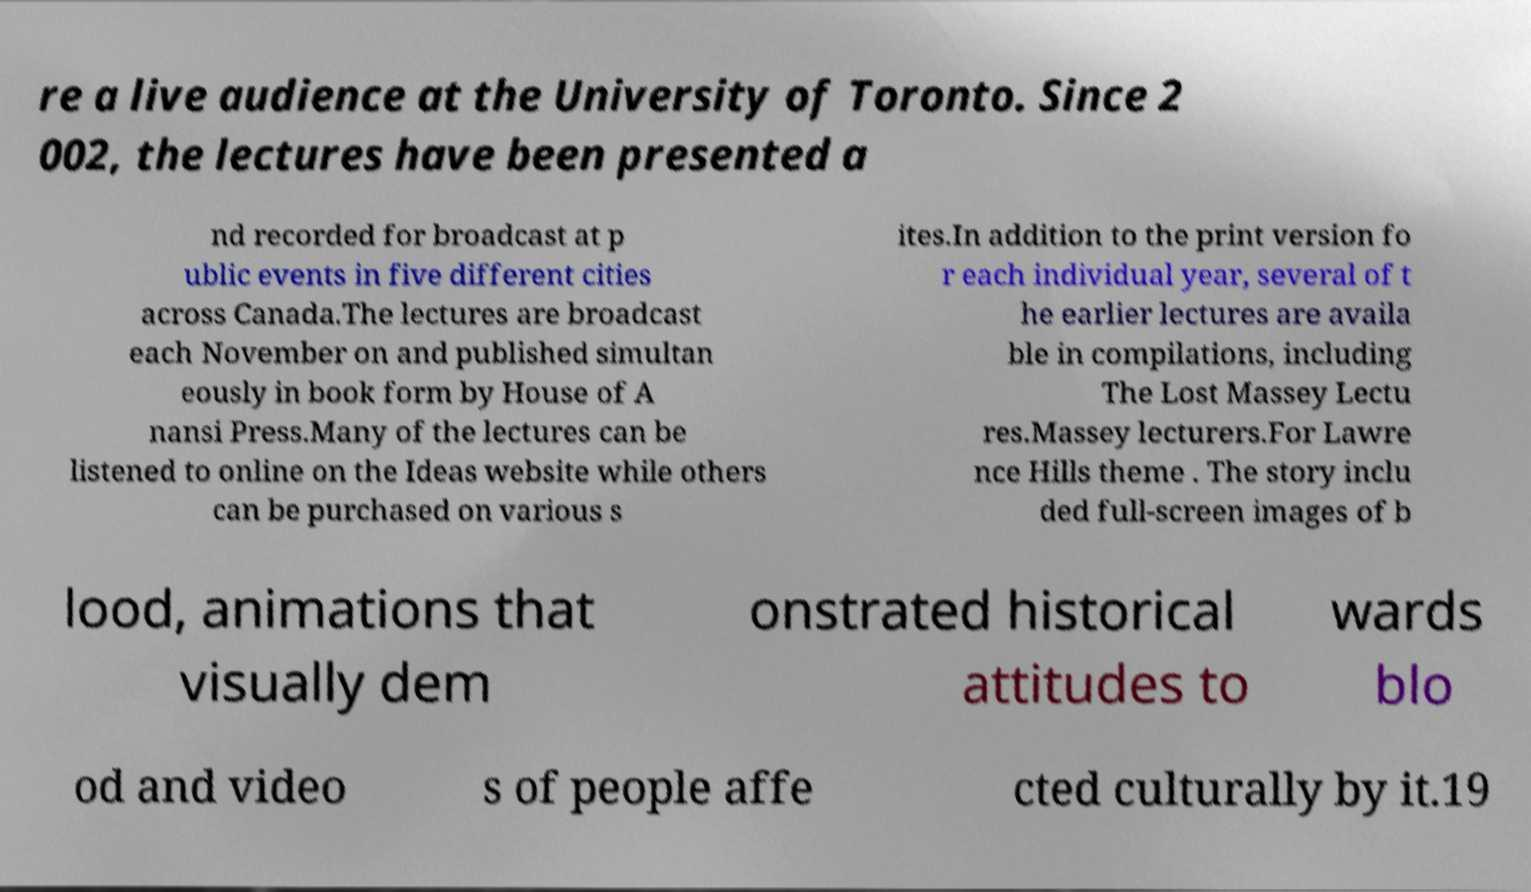Please read and relay the text visible in this image. What does it say? re a live audience at the University of Toronto. Since 2 002, the lectures have been presented a nd recorded for broadcast at p ublic events in five different cities across Canada.The lectures are broadcast each November on and published simultan eously in book form by House of A nansi Press.Many of the lectures can be listened to online on the Ideas website while others can be purchased on various s ites.In addition to the print version fo r each individual year, several of t he earlier lectures are availa ble in compilations, including The Lost Massey Lectu res.Massey lecturers.For Lawre nce Hills theme . The story inclu ded full-screen images of b lood, animations that visually dem onstrated historical attitudes to wards blo od and video s of people affe cted culturally by it.19 